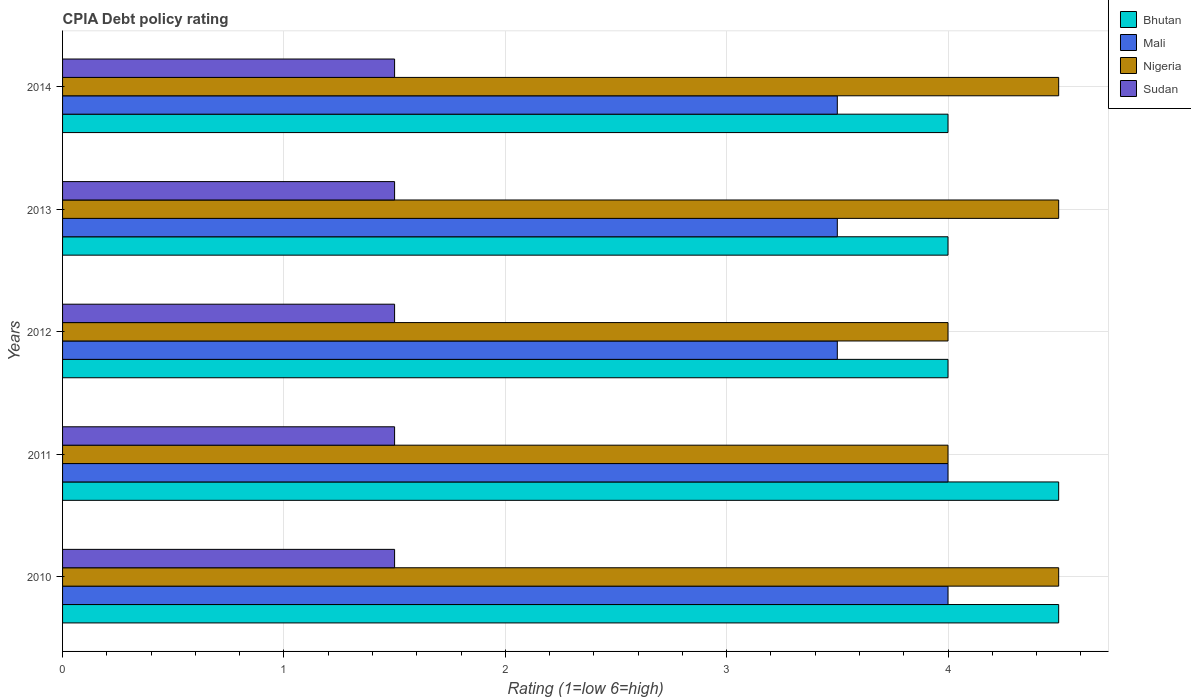How many different coloured bars are there?
Keep it short and to the point. 4. Are the number of bars per tick equal to the number of legend labels?
Make the answer very short. Yes. In how many cases, is the number of bars for a given year not equal to the number of legend labels?
Your response must be concise. 0. What is the CPIA rating in Sudan in 2011?
Provide a short and direct response. 1.5. What is the difference between the CPIA rating in Bhutan in 2010 and that in 2014?
Your answer should be compact. 0.5. What is the difference between the CPIA rating in Bhutan in 2010 and the CPIA rating in Nigeria in 2013?
Provide a succinct answer. 0. What is the average CPIA rating in Bhutan per year?
Keep it short and to the point. 4.2. In how many years, is the CPIA rating in Mali greater than 3 ?
Your answer should be very brief. 5. What is the ratio of the CPIA rating in Mali in 2010 to that in 2014?
Give a very brief answer. 1.14. Is the CPIA rating in Bhutan in 2011 less than that in 2013?
Keep it short and to the point. No. In how many years, is the CPIA rating in Mali greater than the average CPIA rating in Mali taken over all years?
Provide a short and direct response. 2. What does the 3rd bar from the top in 2012 represents?
Your response must be concise. Mali. What does the 1st bar from the bottom in 2013 represents?
Your answer should be very brief. Bhutan. How many bars are there?
Ensure brevity in your answer.  20. Where does the legend appear in the graph?
Your answer should be very brief. Top right. How are the legend labels stacked?
Your answer should be compact. Vertical. What is the title of the graph?
Your answer should be compact. CPIA Debt policy rating. What is the Rating (1=low 6=high) of Nigeria in 2010?
Give a very brief answer. 4.5. What is the Rating (1=low 6=high) in Sudan in 2010?
Ensure brevity in your answer.  1.5. What is the Rating (1=low 6=high) of Mali in 2013?
Give a very brief answer. 3.5. What is the Rating (1=low 6=high) of Nigeria in 2013?
Make the answer very short. 4.5. What is the Rating (1=low 6=high) in Bhutan in 2014?
Make the answer very short. 4. What is the Rating (1=low 6=high) in Nigeria in 2014?
Provide a short and direct response. 4.5. What is the Rating (1=low 6=high) in Sudan in 2014?
Your response must be concise. 1.5. Across all years, what is the minimum Rating (1=low 6=high) in Mali?
Provide a succinct answer. 3.5. What is the total Rating (1=low 6=high) in Mali in the graph?
Your answer should be very brief. 18.5. What is the total Rating (1=low 6=high) of Sudan in the graph?
Your answer should be compact. 7.5. What is the difference between the Rating (1=low 6=high) in Sudan in 2010 and that in 2011?
Your response must be concise. 0. What is the difference between the Rating (1=low 6=high) in Sudan in 2010 and that in 2012?
Your answer should be compact. 0. What is the difference between the Rating (1=low 6=high) of Bhutan in 2010 and that in 2013?
Provide a succinct answer. 0.5. What is the difference between the Rating (1=low 6=high) of Mali in 2010 and that in 2013?
Offer a very short reply. 0.5. What is the difference between the Rating (1=low 6=high) in Nigeria in 2010 and that in 2013?
Provide a succinct answer. 0. What is the difference between the Rating (1=low 6=high) of Sudan in 2010 and that in 2013?
Provide a succinct answer. 0. What is the difference between the Rating (1=low 6=high) of Bhutan in 2010 and that in 2014?
Offer a terse response. 0.5. What is the difference between the Rating (1=low 6=high) of Mali in 2010 and that in 2014?
Your answer should be very brief. 0.5. What is the difference between the Rating (1=low 6=high) of Nigeria in 2010 and that in 2014?
Provide a short and direct response. 0. What is the difference between the Rating (1=low 6=high) in Bhutan in 2011 and that in 2012?
Provide a short and direct response. 0.5. What is the difference between the Rating (1=low 6=high) of Nigeria in 2011 and that in 2012?
Offer a terse response. 0. What is the difference between the Rating (1=low 6=high) in Bhutan in 2011 and that in 2013?
Offer a very short reply. 0.5. What is the difference between the Rating (1=low 6=high) in Mali in 2011 and that in 2013?
Your response must be concise. 0.5. What is the difference between the Rating (1=low 6=high) in Nigeria in 2011 and that in 2013?
Your response must be concise. -0.5. What is the difference between the Rating (1=low 6=high) of Sudan in 2011 and that in 2013?
Provide a succinct answer. 0. What is the difference between the Rating (1=low 6=high) of Mali in 2011 and that in 2014?
Your answer should be very brief. 0.5. What is the difference between the Rating (1=low 6=high) of Sudan in 2011 and that in 2014?
Keep it short and to the point. 0. What is the difference between the Rating (1=low 6=high) of Mali in 2012 and that in 2013?
Give a very brief answer. 0. What is the difference between the Rating (1=low 6=high) of Nigeria in 2012 and that in 2013?
Your response must be concise. -0.5. What is the difference between the Rating (1=low 6=high) in Bhutan in 2012 and that in 2014?
Offer a terse response. 0. What is the difference between the Rating (1=low 6=high) of Mali in 2012 and that in 2014?
Provide a succinct answer. 0. What is the difference between the Rating (1=low 6=high) of Sudan in 2012 and that in 2014?
Provide a succinct answer. 0. What is the difference between the Rating (1=low 6=high) of Mali in 2013 and that in 2014?
Your response must be concise. 0. What is the difference between the Rating (1=low 6=high) in Sudan in 2013 and that in 2014?
Keep it short and to the point. 0. What is the difference between the Rating (1=low 6=high) of Bhutan in 2010 and the Rating (1=low 6=high) of Mali in 2011?
Keep it short and to the point. 0.5. What is the difference between the Rating (1=low 6=high) of Bhutan in 2010 and the Rating (1=low 6=high) of Sudan in 2011?
Your response must be concise. 3. What is the difference between the Rating (1=low 6=high) of Mali in 2010 and the Rating (1=low 6=high) of Nigeria in 2011?
Your answer should be very brief. 0. What is the difference between the Rating (1=low 6=high) of Nigeria in 2010 and the Rating (1=low 6=high) of Sudan in 2011?
Keep it short and to the point. 3. What is the difference between the Rating (1=low 6=high) in Bhutan in 2010 and the Rating (1=low 6=high) in Mali in 2012?
Your response must be concise. 1. What is the difference between the Rating (1=low 6=high) of Bhutan in 2010 and the Rating (1=low 6=high) of Nigeria in 2013?
Ensure brevity in your answer.  0. What is the difference between the Rating (1=low 6=high) in Bhutan in 2010 and the Rating (1=low 6=high) in Sudan in 2013?
Make the answer very short. 3. What is the difference between the Rating (1=low 6=high) in Nigeria in 2010 and the Rating (1=low 6=high) in Sudan in 2013?
Ensure brevity in your answer.  3. What is the difference between the Rating (1=low 6=high) of Bhutan in 2010 and the Rating (1=low 6=high) of Mali in 2014?
Give a very brief answer. 1. What is the difference between the Rating (1=low 6=high) of Bhutan in 2010 and the Rating (1=low 6=high) of Nigeria in 2014?
Provide a short and direct response. 0. What is the difference between the Rating (1=low 6=high) of Bhutan in 2010 and the Rating (1=low 6=high) of Sudan in 2014?
Your answer should be very brief. 3. What is the difference between the Rating (1=low 6=high) of Mali in 2010 and the Rating (1=low 6=high) of Nigeria in 2014?
Your answer should be very brief. -0.5. What is the difference between the Rating (1=low 6=high) of Bhutan in 2011 and the Rating (1=low 6=high) of Mali in 2012?
Your answer should be very brief. 1. What is the difference between the Rating (1=low 6=high) in Bhutan in 2011 and the Rating (1=low 6=high) in Nigeria in 2012?
Your answer should be very brief. 0.5. What is the difference between the Rating (1=low 6=high) of Bhutan in 2011 and the Rating (1=low 6=high) of Sudan in 2012?
Offer a very short reply. 3. What is the difference between the Rating (1=low 6=high) in Mali in 2011 and the Rating (1=low 6=high) in Nigeria in 2012?
Offer a terse response. 0. What is the difference between the Rating (1=low 6=high) of Nigeria in 2011 and the Rating (1=low 6=high) of Sudan in 2012?
Offer a terse response. 2.5. What is the difference between the Rating (1=low 6=high) of Bhutan in 2011 and the Rating (1=low 6=high) of Mali in 2013?
Your answer should be compact. 1. What is the difference between the Rating (1=low 6=high) in Bhutan in 2011 and the Rating (1=low 6=high) in Nigeria in 2013?
Your response must be concise. 0. What is the difference between the Rating (1=low 6=high) in Bhutan in 2011 and the Rating (1=low 6=high) in Sudan in 2013?
Provide a succinct answer. 3. What is the difference between the Rating (1=low 6=high) in Mali in 2011 and the Rating (1=low 6=high) in Nigeria in 2013?
Provide a short and direct response. -0.5. What is the difference between the Rating (1=low 6=high) of Mali in 2011 and the Rating (1=low 6=high) of Sudan in 2013?
Keep it short and to the point. 2.5. What is the difference between the Rating (1=low 6=high) in Bhutan in 2011 and the Rating (1=low 6=high) in Mali in 2014?
Keep it short and to the point. 1. What is the difference between the Rating (1=low 6=high) in Bhutan in 2011 and the Rating (1=low 6=high) in Nigeria in 2014?
Provide a succinct answer. 0. What is the difference between the Rating (1=low 6=high) of Mali in 2011 and the Rating (1=low 6=high) of Nigeria in 2014?
Offer a very short reply. -0.5. What is the difference between the Rating (1=low 6=high) in Mali in 2011 and the Rating (1=low 6=high) in Sudan in 2014?
Give a very brief answer. 2.5. What is the difference between the Rating (1=low 6=high) of Nigeria in 2011 and the Rating (1=low 6=high) of Sudan in 2014?
Offer a terse response. 2.5. What is the difference between the Rating (1=low 6=high) of Bhutan in 2012 and the Rating (1=low 6=high) of Sudan in 2013?
Ensure brevity in your answer.  2.5. What is the difference between the Rating (1=low 6=high) in Mali in 2012 and the Rating (1=low 6=high) in Nigeria in 2013?
Give a very brief answer. -1. What is the difference between the Rating (1=low 6=high) of Nigeria in 2012 and the Rating (1=low 6=high) of Sudan in 2013?
Give a very brief answer. 2.5. What is the difference between the Rating (1=low 6=high) in Bhutan in 2012 and the Rating (1=low 6=high) in Nigeria in 2014?
Keep it short and to the point. -0.5. What is the difference between the Rating (1=low 6=high) of Mali in 2012 and the Rating (1=low 6=high) of Sudan in 2014?
Provide a short and direct response. 2. What is the difference between the Rating (1=low 6=high) of Nigeria in 2012 and the Rating (1=low 6=high) of Sudan in 2014?
Your response must be concise. 2.5. What is the difference between the Rating (1=low 6=high) of Bhutan in 2013 and the Rating (1=low 6=high) of Nigeria in 2014?
Provide a short and direct response. -0.5. What is the difference between the Rating (1=low 6=high) in Bhutan in 2013 and the Rating (1=low 6=high) in Sudan in 2014?
Offer a very short reply. 2.5. What is the difference between the Rating (1=low 6=high) in Nigeria in 2013 and the Rating (1=low 6=high) in Sudan in 2014?
Make the answer very short. 3. What is the average Rating (1=low 6=high) of Mali per year?
Your response must be concise. 3.7. What is the average Rating (1=low 6=high) of Nigeria per year?
Ensure brevity in your answer.  4.3. In the year 2010, what is the difference between the Rating (1=low 6=high) in Bhutan and Rating (1=low 6=high) in Nigeria?
Your answer should be compact. 0. In the year 2010, what is the difference between the Rating (1=low 6=high) in Mali and Rating (1=low 6=high) in Sudan?
Ensure brevity in your answer.  2.5. In the year 2011, what is the difference between the Rating (1=low 6=high) in Bhutan and Rating (1=low 6=high) in Nigeria?
Ensure brevity in your answer.  0.5. In the year 2011, what is the difference between the Rating (1=low 6=high) in Mali and Rating (1=low 6=high) in Sudan?
Your answer should be very brief. 2.5. In the year 2012, what is the difference between the Rating (1=low 6=high) of Bhutan and Rating (1=low 6=high) of Mali?
Make the answer very short. 0.5. In the year 2012, what is the difference between the Rating (1=low 6=high) in Bhutan and Rating (1=low 6=high) in Nigeria?
Make the answer very short. 0. In the year 2012, what is the difference between the Rating (1=low 6=high) of Bhutan and Rating (1=low 6=high) of Sudan?
Give a very brief answer. 2.5. In the year 2012, what is the difference between the Rating (1=low 6=high) in Mali and Rating (1=low 6=high) in Nigeria?
Your response must be concise. -0.5. In the year 2013, what is the difference between the Rating (1=low 6=high) of Bhutan and Rating (1=low 6=high) of Mali?
Offer a terse response. 0.5. In the year 2013, what is the difference between the Rating (1=low 6=high) in Mali and Rating (1=low 6=high) in Sudan?
Ensure brevity in your answer.  2. In the year 2014, what is the difference between the Rating (1=low 6=high) of Bhutan and Rating (1=low 6=high) of Mali?
Your answer should be compact. 0.5. In the year 2014, what is the difference between the Rating (1=low 6=high) in Bhutan and Rating (1=low 6=high) in Sudan?
Provide a succinct answer. 2.5. In the year 2014, what is the difference between the Rating (1=low 6=high) in Mali and Rating (1=low 6=high) in Nigeria?
Your answer should be very brief. -1. In the year 2014, what is the difference between the Rating (1=low 6=high) in Mali and Rating (1=low 6=high) in Sudan?
Offer a very short reply. 2. In the year 2014, what is the difference between the Rating (1=low 6=high) of Nigeria and Rating (1=low 6=high) of Sudan?
Make the answer very short. 3. What is the ratio of the Rating (1=low 6=high) of Mali in 2010 to that in 2011?
Keep it short and to the point. 1. What is the ratio of the Rating (1=low 6=high) in Nigeria in 2010 to that in 2011?
Provide a succinct answer. 1.12. What is the ratio of the Rating (1=low 6=high) in Sudan in 2010 to that in 2011?
Keep it short and to the point. 1. What is the ratio of the Rating (1=low 6=high) of Bhutan in 2010 to that in 2012?
Your response must be concise. 1.12. What is the ratio of the Rating (1=low 6=high) in Nigeria in 2010 to that in 2012?
Provide a succinct answer. 1.12. What is the ratio of the Rating (1=low 6=high) in Mali in 2010 to that in 2013?
Keep it short and to the point. 1.14. What is the ratio of the Rating (1=low 6=high) in Bhutan in 2010 to that in 2014?
Your answer should be very brief. 1.12. What is the ratio of the Rating (1=low 6=high) in Mali in 2010 to that in 2014?
Offer a very short reply. 1.14. What is the ratio of the Rating (1=low 6=high) of Mali in 2011 to that in 2012?
Make the answer very short. 1.14. What is the ratio of the Rating (1=low 6=high) in Sudan in 2011 to that in 2012?
Make the answer very short. 1. What is the ratio of the Rating (1=low 6=high) in Bhutan in 2011 to that in 2013?
Keep it short and to the point. 1.12. What is the ratio of the Rating (1=low 6=high) in Mali in 2011 to that in 2013?
Ensure brevity in your answer.  1.14. What is the ratio of the Rating (1=low 6=high) of Nigeria in 2011 to that in 2013?
Your answer should be very brief. 0.89. What is the ratio of the Rating (1=low 6=high) of Mali in 2011 to that in 2014?
Keep it short and to the point. 1.14. What is the ratio of the Rating (1=low 6=high) in Sudan in 2011 to that in 2014?
Offer a terse response. 1. What is the ratio of the Rating (1=low 6=high) in Bhutan in 2012 to that in 2013?
Your answer should be very brief. 1. What is the ratio of the Rating (1=low 6=high) of Sudan in 2012 to that in 2013?
Provide a succinct answer. 1. What is the ratio of the Rating (1=low 6=high) in Bhutan in 2012 to that in 2014?
Ensure brevity in your answer.  1. What is the ratio of the Rating (1=low 6=high) in Mali in 2012 to that in 2014?
Your answer should be very brief. 1. What is the ratio of the Rating (1=low 6=high) of Nigeria in 2013 to that in 2014?
Provide a short and direct response. 1. What is the ratio of the Rating (1=low 6=high) in Sudan in 2013 to that in 2014?
Your answer should be very brief. 1. What is the difference between the highest and the second highest Rating (1=low 6=high) in Bhutan?
Keep it short and to the point. 0. What is the difference between the highest and the second highest Rating (1=low 6=high) of Mali?
Give a very brief answer. 0. What is the difference between the highest and the second highest Rating (1=low 6=high) of Sudan?
Your response must be concise. 0. What is the difference between the highest and the lowest Rating (1=low 6=high) in Bhutan?
Provide a short and direct response. 0.5. What is the difference between the highest and the lowest Rating (1=low 6=high) of Mali?
Ensure brevity in your answer.  0.5. 